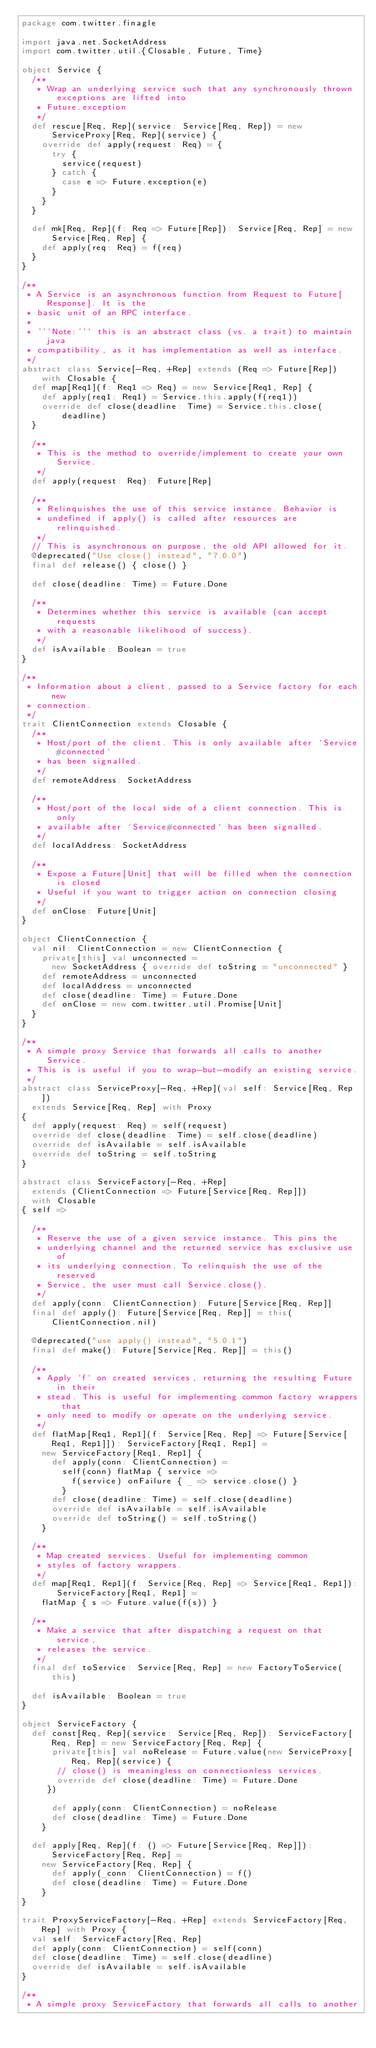Convert code to text. <code><loc_0><loc_0><loc_500><loc_500><_Scala_>package com.twitter.finagle

import java.net.SocketAddress
import com.twitter.util.{Closable, Future, Time}

object Service {
  /**
   * Wrap an underlying service such that any synchronously thrown exceptions are lifted into
   * Future.exception
   */
  def rescue[Req, Rep](service: Service[Req, Rep]) = new ServiceProxy[Req, Rep](service) {
    override def apply(request: Req) = {
      try {
        service(request)
      } catch {
        case e => Future.exception(e)
      }
    }
  }

  def mk[Req, Rep](f: Req => Future[Rep]): Service[Req, Rep] = new Service[Req, Rep] {
    def apply(req: Req) = f(req)
  }
}

/**
 * A Service is an asynchronous function from Request to Future[Response]. It is the
 * basic unit of an RPC interface.
 *
 * '''Note:''' this is an abstract class (vs. a trait) to maintain java
 * compatibility, as it has implementation as well as interface.
 */
abstract class Service[-Req, +Rep] extends (Req => Future[Rep]) with Closable {
  def map[Req1](f: Req1 => Req) = new Service[Req1, Rep] {
    def apply(req1: Req1) = Service.this.apply(f(req1))
    override def close(deadline: Time) = Service.this.close(deadline)
  }

  /**
   * This is the method to override/implement to create your own Service.
   */
  def apply(request: Req): Future[Rep]

  /**
   * Relinquishes the use of this service instance. Behavior is
   * undefined if apply() is called after resources are relinquished.
   */
  // This is asynchronous on purpose, the old API allowed for it.
  @deprecated("Use close() instead", "7.0.0")
  final def release() { close() }

  def close(deadline: Time) = Future.Done

  /**
   * Determines whether this service is available (can accept requests
   * with a reasonable likelihood of success).
   */
  def isAvailable: Boolean = true
}

/**
 * Information about a client, passed to a Service factory for each new
 * connection.
 */
trait ClientConnection extends Closable {
  /**
   * Host/port of the client. This is only available after `Service#connected`
   * has been signalled.
   */
  def remoteAddress: SocketAddress

  /**
   * Host/port of the local side of a client connection. This is only
   * available after `Service#connected` has been signalled.
   */
  def localAddress: SocketAddress

  /**
   * Expose a Future[Unit] that will be filled when the connection is closed
   * Useful if you want to trigger action on connection closing
   */
  def onClose: Future[Unit]
}

object ClientConnection {
  val nil: ClientConnection = new ClientConnection {
    private[this] val unconnected =
      new SocketAddress { override def toString = "unconnected" }
    def remoteAddress = unconnected
    def localAddress = unconnected
    def close(deadline: Time) = Future.Done
    def onClose = new com.twitter.util.Promise[Unit]
  }
}

/**
 * A simple proxy Service that forwards all calls to another Service.
 * This is is useful if you to wrap-but-modify an existing service.
 */
abstract class ServiceProxy[-Req, +Rep](val self: Service[Req, Rep])
  extends Service[Req, Rep] with Proxy
{
  def apply(request: Req) = self(request)
  override def close(deadline: Time) = self.close(deadline)
  override def isAvailable = self.isAvailable
  override def toString = self.toString
}

abstract class ServiceFactory[-Req, +Rep]
  extends (ClientConnection => Future[Service[Req, Rep]])
  with Closable
{ self =>

  /**
   * Reserve the use of a given service instance. This pins the
   * underlying channel and the returned service has exclusive use of
   * its underlying connection. To relinquish the use of the reserved
   * Service, the user must call Service.close().
   */
  def apply(conn: ClientConnection): Future[Service[Req, Rep]]
  final def apply(): Future[Service[Req, Rep]] = this(ClientConnection.nil)

  @deprecated("use apply() instead", "5.0.1")
  final def make(): Future[Service[Req, Rep]] = this()

  /**
   * Apply `f` on created services, returning the resulting Future in their
   * stead. This is useful for implementing common factory wrappers that
   * only need to modify or operate on the underlying service.
   */
  def flatMap[Req1, Rep1](f: Service[Req, Rep] => Future[Service[Req1, Rep1]]): ServiceFactory[Req1, Rep1] =
    new ServiceFactory[Req1, Rep1] {
      def apply(conn: ClientConnection) =
        self(conn) flatMap { service =>
          f(service) onFailure { _ => service.close() }
        }
      def close(deadline: Time) = self.close(deadline)
      override def isAvailable = self.isAvailable
      override def toString() = self.toString()
    }

  /**
   * Map created services. Useful for implementing common
   * styles of factory wrappers.
   */
  def map[Req1, Rep1](f: Service[Req, Rep] => Service[Req1, Rep1]): ServiceFactory[Req1, Rep1] =
    flatMap { s => Future.value(f(s)) }

  /**
   * Make a service that after dispatching a request on that service,
   * releases the service.
   */
  final def toService: Service[Req, Rep] = new FactoryToService(this)

  def isAvailable: Boolean = true
}

object ServiceFactory {
  def const[Req, Rep](service: Service[Req, Rep]): ServiceFactory[Req, Rep] = new ServiceFactory[Req, Rep] {
      private[this] val noRelease = Future.value(new ServiceProxy[Req, Rep](service) {
       // close() is meaningless on connectionless services.
       override def close(deadline: Time) = Future.Done
     })

      def apply(conn: ClientConnection) = noRelease
      def close(deadline: Time) = Future.Done
    }

  def apply[Req, Rep](f: () => Future[Service[Req, Rep]]): ServiceFactory[Req, Rep] =
    new ServiceFactory[Req, Rep] {
      def apply(_conn: ClientConnection) = f()
      def close(deadline: Time) = Future.Done
    }
}

trait ProxyServiceFactory[-Req, +Rep] extends ServiceFactory[Req, Rep] with Proxy {
  val self: ServiceFactory[Req, Rep]
  def apply(conn: ClientConnection) = self(conn)
  def close(deadline: Time) = self.close(deadline)
  override def isAvailable = self.isAvailable
}

/**
 * A simple proxy ServiceFactory that forwards all calls to another</code> 